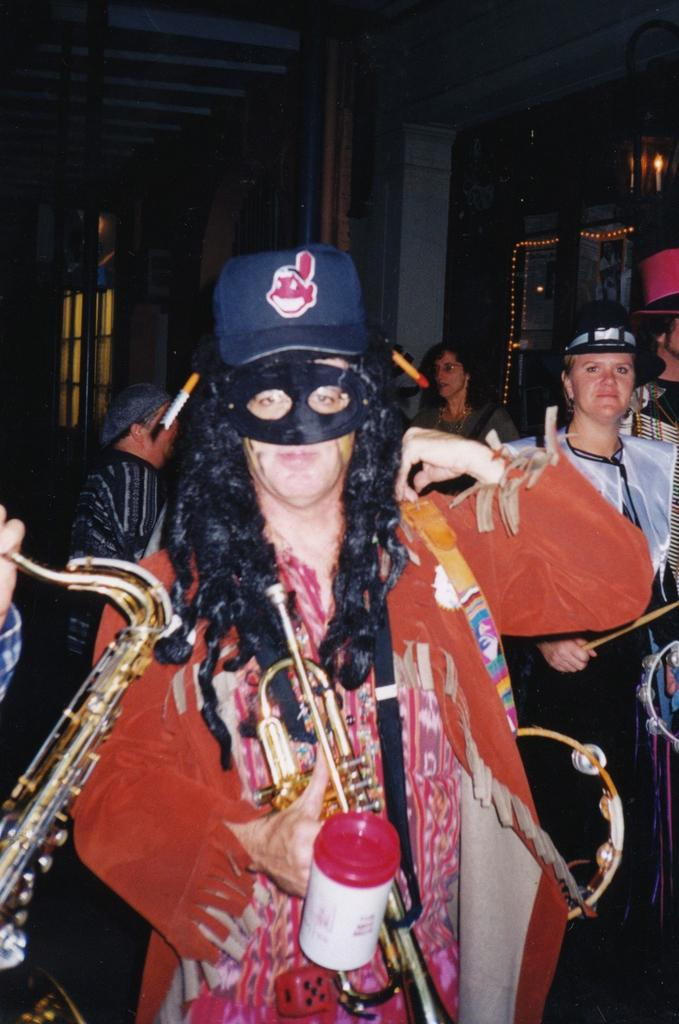How many people are in the group that is visible in the image? There is a group of people in the image, but the exact number is not specified. What are some people in the group wearing? Some people in the group are wearing costumes. What are some people in the group holding? Some people in the group are holding musical instruments. What can be seen in the background of the image? There are lights visible in the background of the image. Reasoning: Let's think step by identifying the main subjects and objects in the image based on the provided facts. We then formulate questions that focus on the characteristics of these subjects and objects, ensuring that each question can be answered definitively with the information given. We avoid yes/no questions and ensure that the language is simple and clear. Absurd Question/Answer: What type of whip is being used by the people in the image? There is no whip present in the image. What scientific discoveries are being discussed by the group in the image? There is no indication of any scientific discussions taking place in the image. What type of whip is being used by the people in the image? There is no whip present in the image. What scientific discoveries are being discussed by the group in the image? There is no indication of any scientific discussions taking place in the image. 